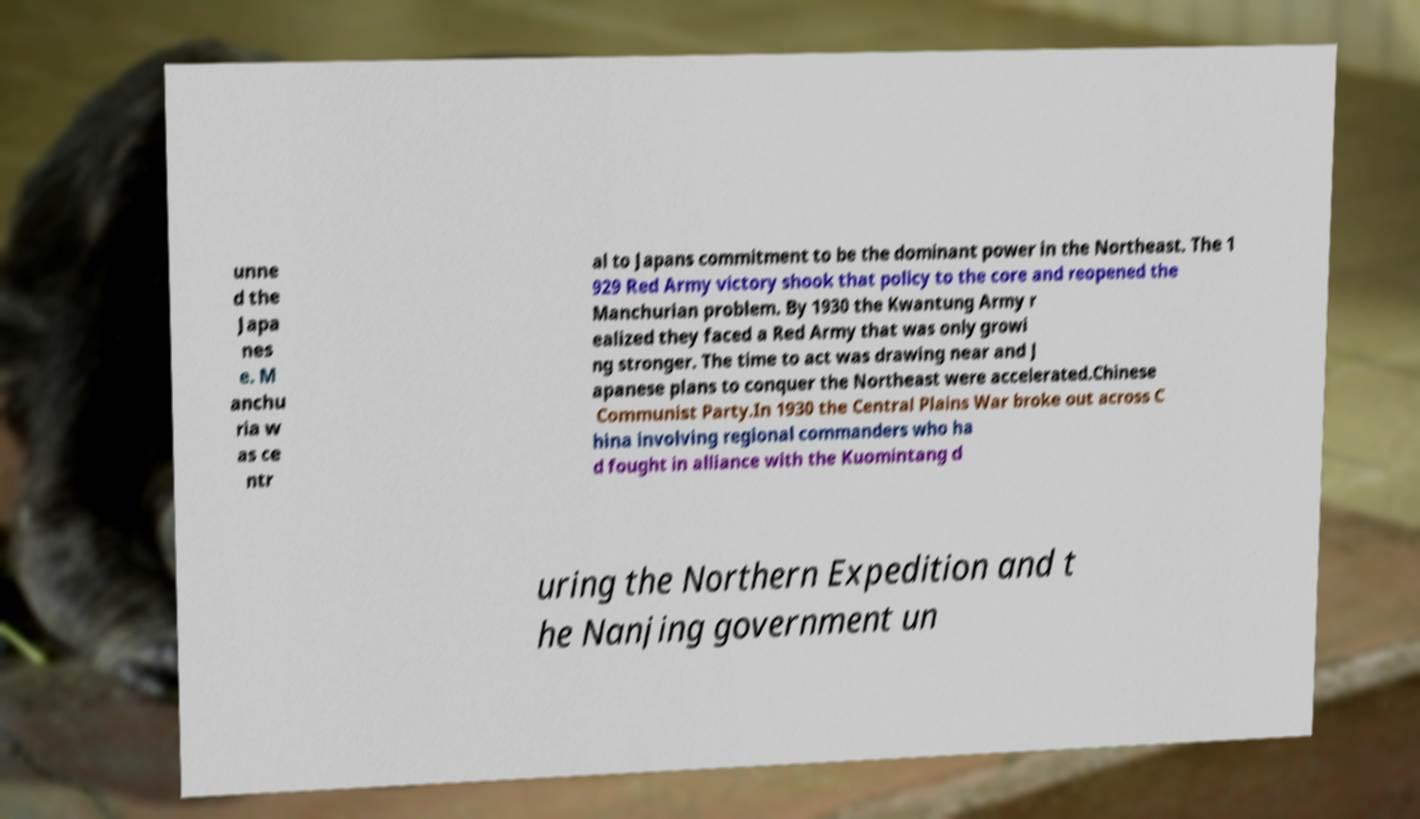What messages or text are displayed in this image? I need them in a readable, typed format. unne d the Japa nes e. M anchu ria w as ce ntr al to Japans commitment to be the dominant power in the Northeast. The 1 929 Red Army victory shook that policy to the core and reopened the Manchurian problem. By 1930 the Kwantung Army r ealized they faced a Red Army that was only growi ng stronger. The time to act was drawing near and J apanese plans to conquer the Northeast were accelerated.Chinese Communist Party.In 1930 the Central Plains War broke out across C hina involving regional commanders who ha d fought in alliance with the Kuomintang d uring the Northern Expedition and t he Nanjing government un 